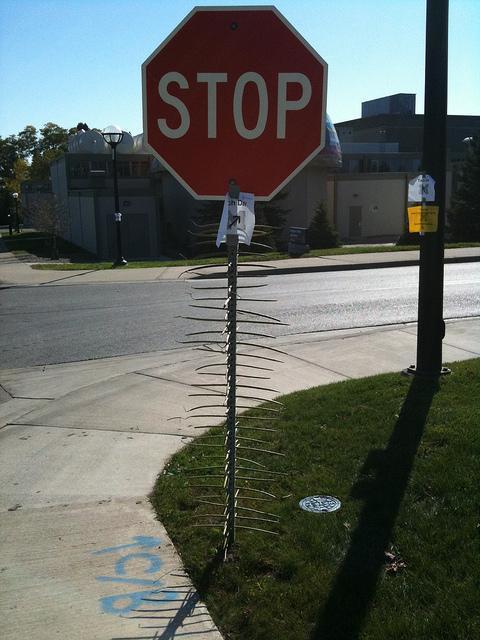How many people are wearing a white dress?
Give a very brief answer. 0. 